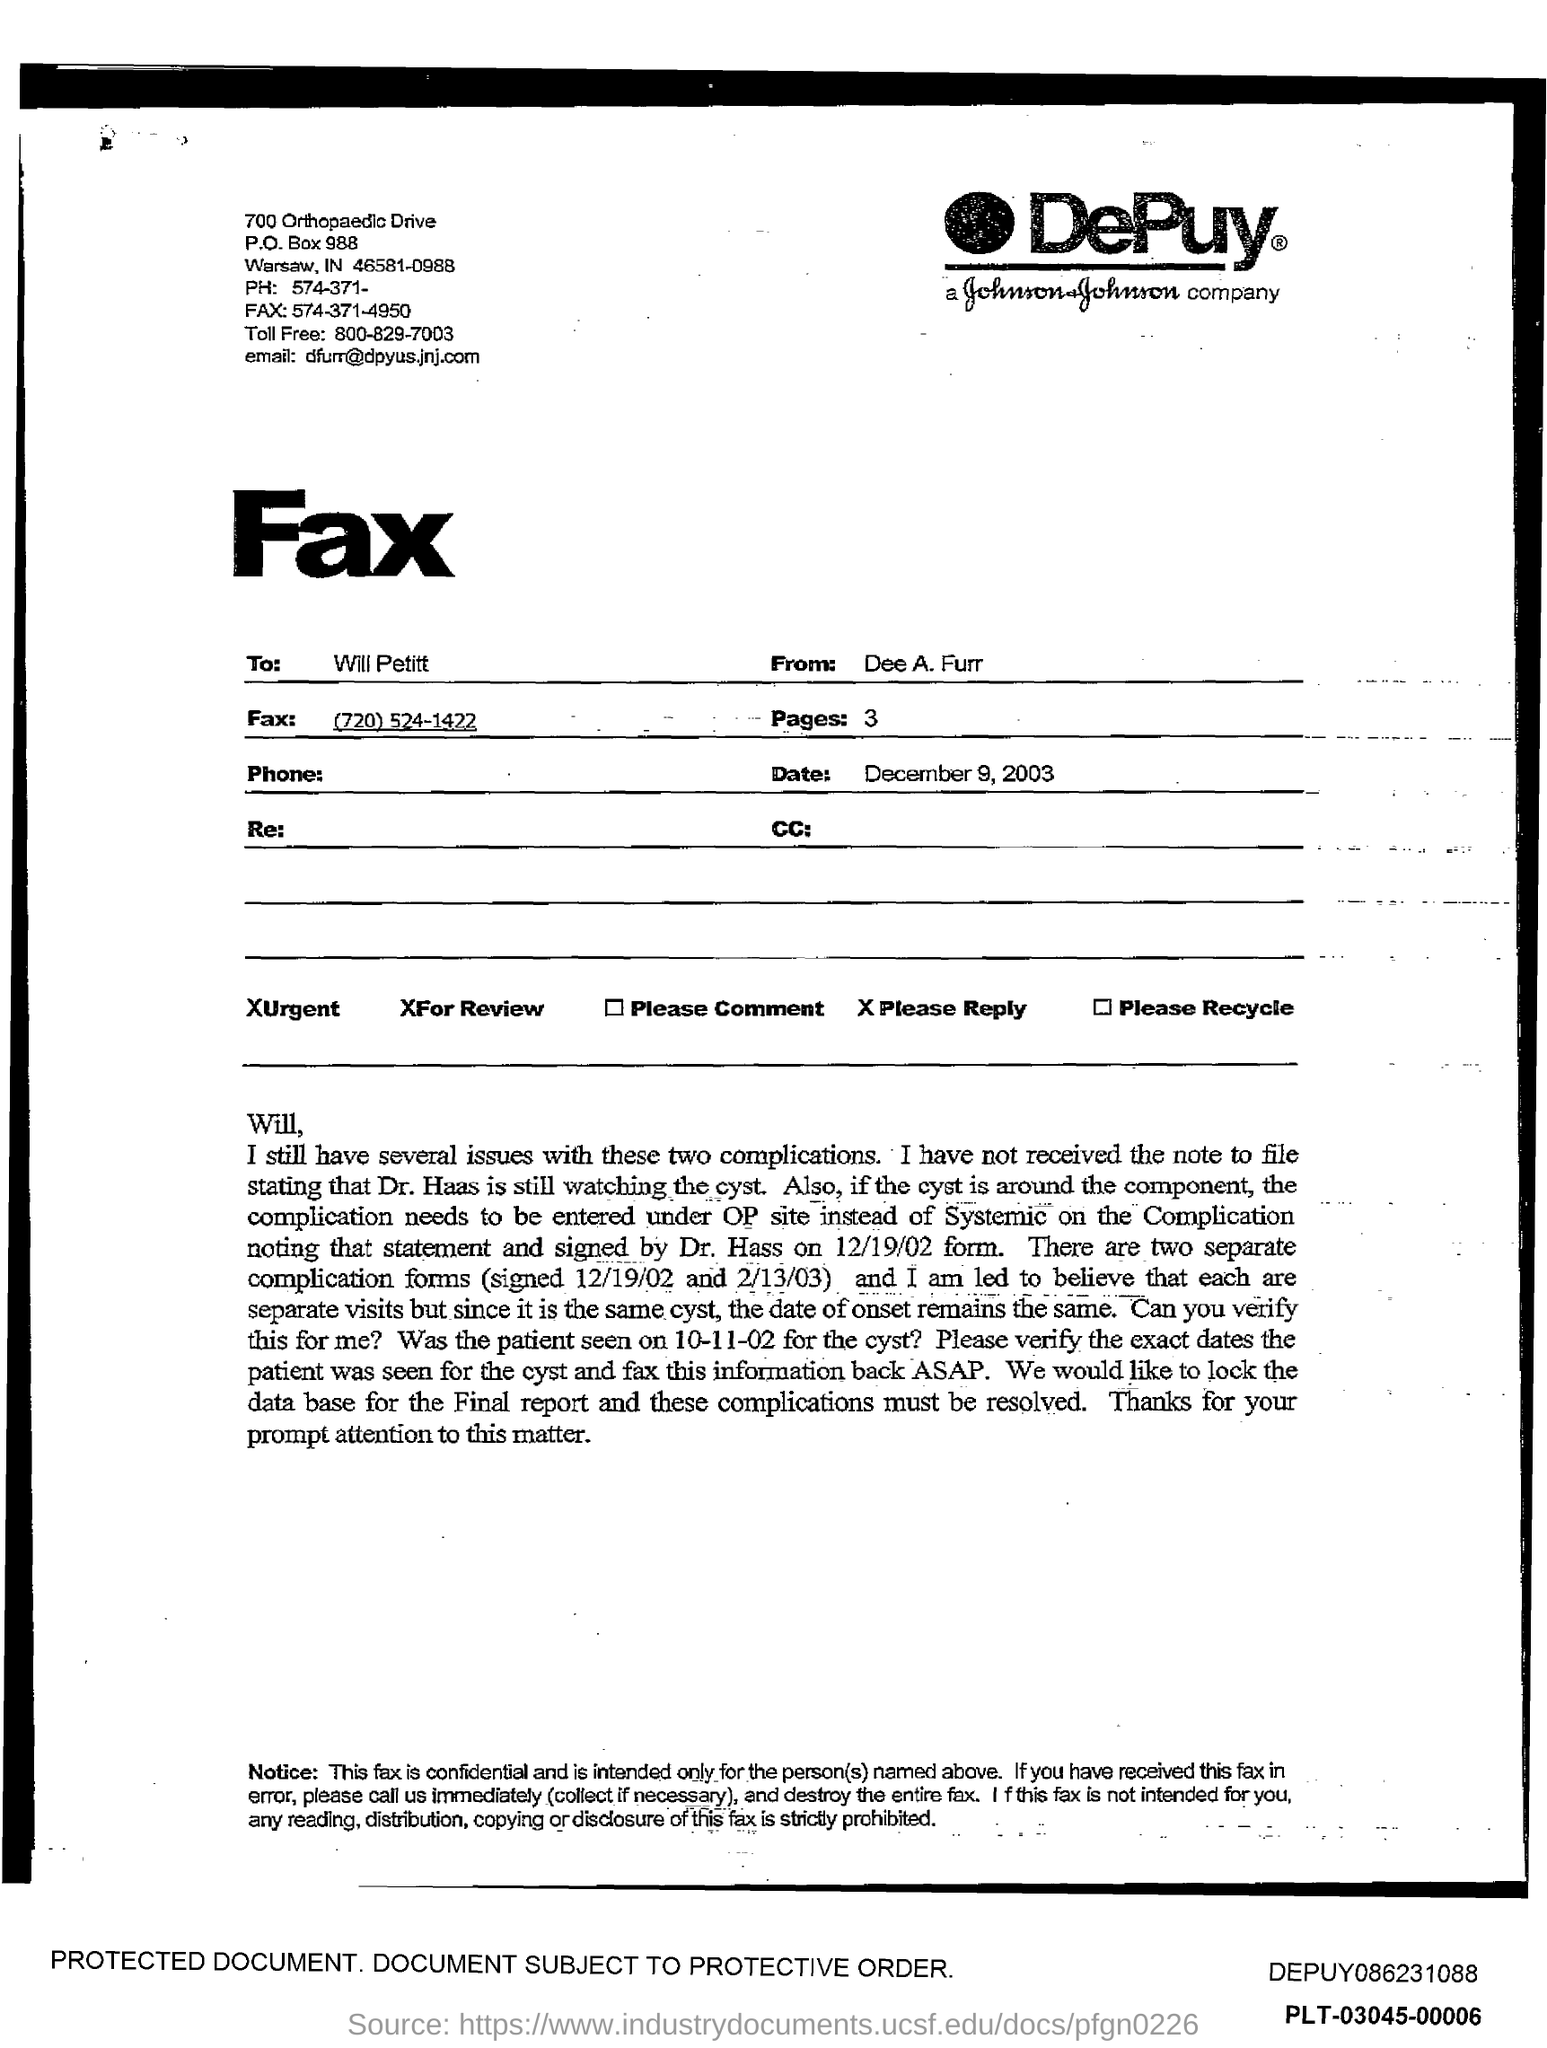Indicate a few pertinent items in this graphic. The number of pages in the fax is three. The sender of the fax is Dee A. Furr. The addressee of the fax is WILL PETITT. The given fax number is (720) 524-1422. 